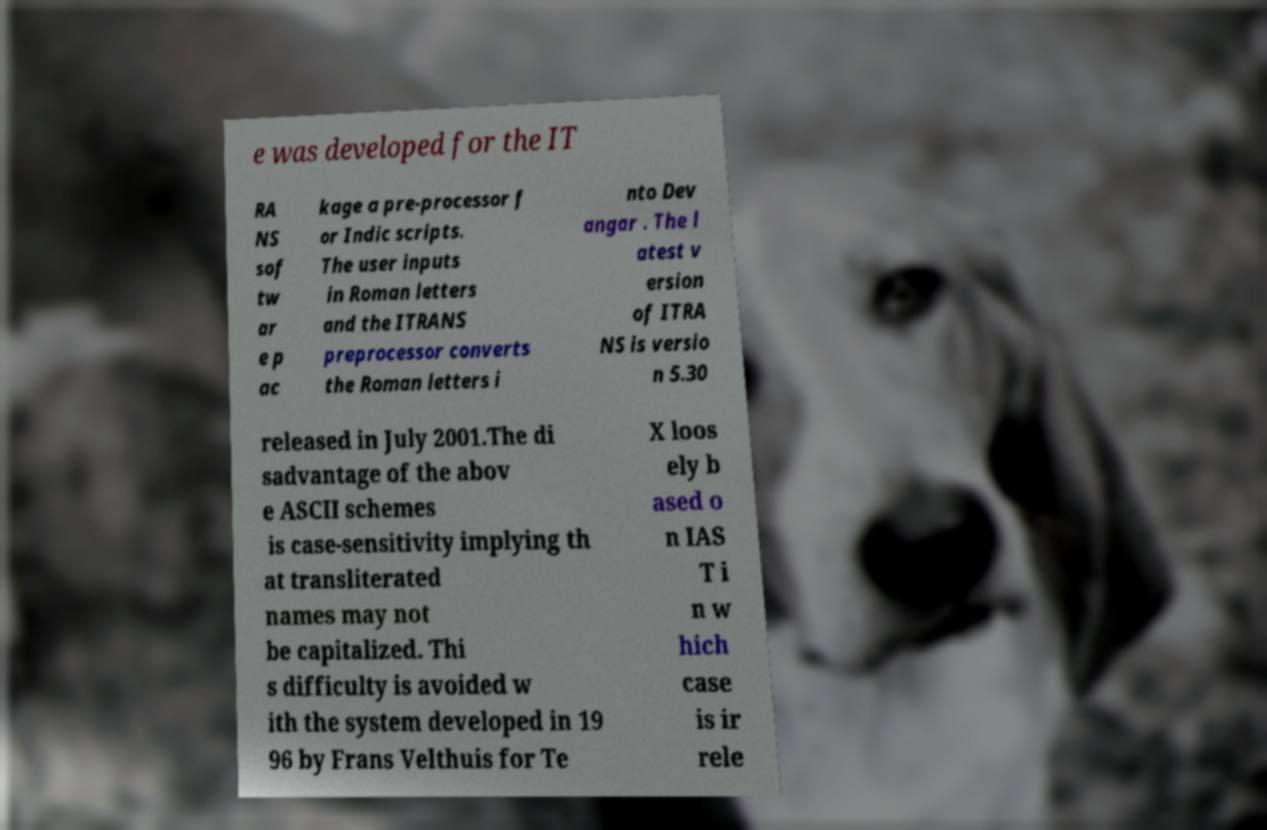There's text embedded in this image that I need extracted. Can you transcribe it verbatim? e was developed for the IT RA NS sof tw ar e p ac kage a pre-processor f or Indic scripts. The user inputs in Roman letters and the ITRANS preprocessor converts the Roman letters i nto Dev angar . The l atest v ersion of ITRA NS is versio n 5.30 released in July 2001.The di sadvantage of the abov e ASCII schemes is case-sensitivity implying th at transliterated names may not be capitalized. Thi s difficulty is avoided w ith the system developed in 19 96 by Frans Velthuis for Te X loos ely b ased o n IAS T i n w hich case is ir rele 